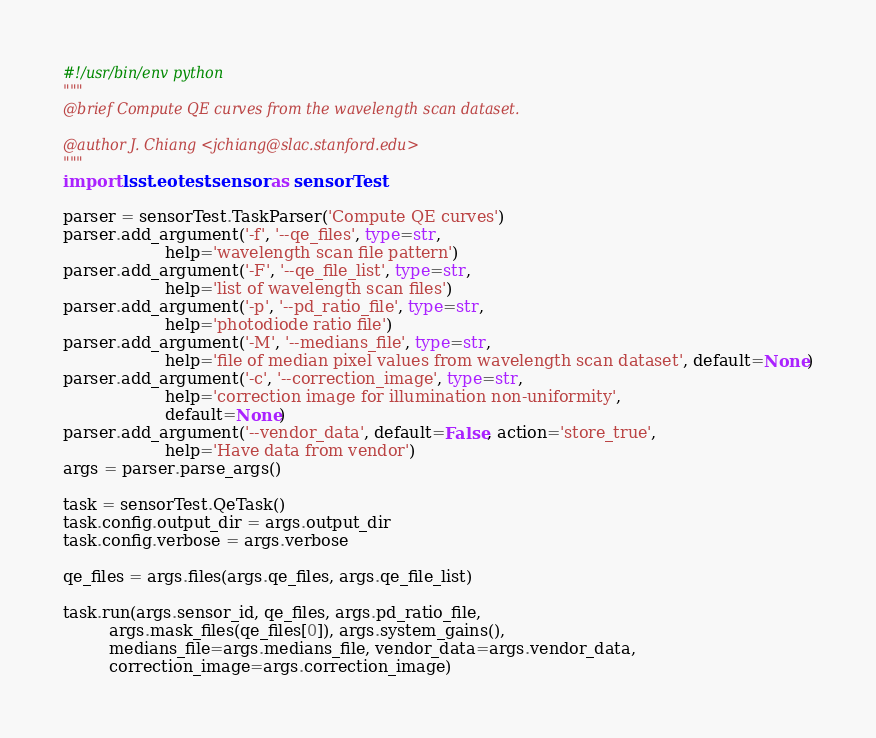<code> <loc_0><loc_0><loc_500><loc_500><_Python_>#!/usr/bin/env python
"""
@brief Compute QE curves from the wavelength scan dataset.

@author J. Chiang <jchiang@slac.stanford.edu>
"""
import lsst.eotest.sensor as sensorTest

parser = sensorTest.TaskParser('Compute QE curves')
parser.add_argument('-f', '--qe_files', type=str,
                    help='wavelength scan file pattern')
parser.add_argument('-F', '--qe_file_list', type=str,
                    help='list of wavelength scan files')
parser.add_argument('-p', '--pd_ratio_file', type=str,
                    help='photodiode ratio file')
parser.add_argument('-M', '--medians_file', type=str,
                    help='file of median pixel values from wavelength scan dataset', default=None)
parser.add_argument('-c', '--correction_image', type=str,
                    help='correction image for illumination non-uniformity',
                    default=None)
parser.add_argument('--vendor_data', default=False, action='store_true',
                    help='Have data from vendor')
args = parser.parse_args()

task = sensorTest.QeTask()
task.config.output_dir = args.output_dir
task.config.verbose = args.verbose

qe_files = args.files(args.qe_files, args.qe_file_list)

task.run(args.sensor_id, qe_files, args.pd_ratio_file,
         args.mask_files(qe_files[0]), args.system_gains(),
         medians_file=args.medians_file, vendor_data=args.vendor_data,
         correction_image=args.correction_image)
</code> 